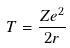Convert formula to latex. <formula><loc_0><loc_0><loc_500><loc_500>T = \frac { Z e ^ { 2 } } { 2 r }</formula> 